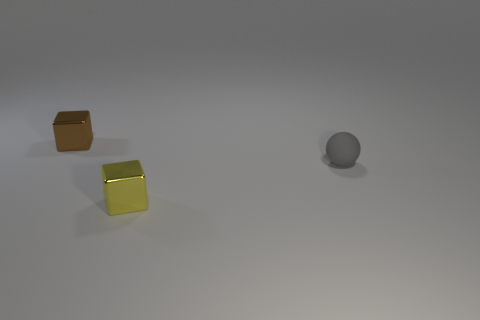Add 1 small objects. How many objects exist? 4 Subtract all balls. How many objects are left? 2 Subtract all gray spheres. Subtract all small gray metal blocks. How many objects are left? 2 Add 2 small shiny things. How many small shiny things are left? 4 Add 2 big gray spheres. How many big gray spheres exist? 2 Subtract 0 red cylinders. How many objects are left? 3 